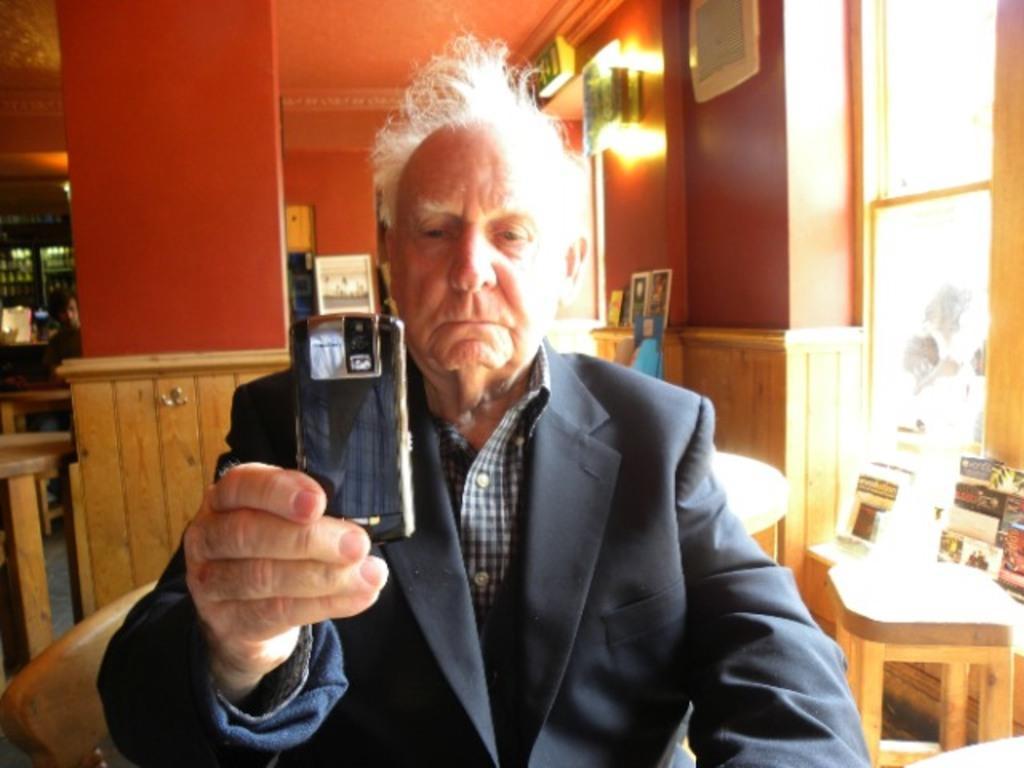Can you describe this image briefly? In this image I see a man who is wearing a suit and holding a mobile. In the background I see another person, few tables and the window. 